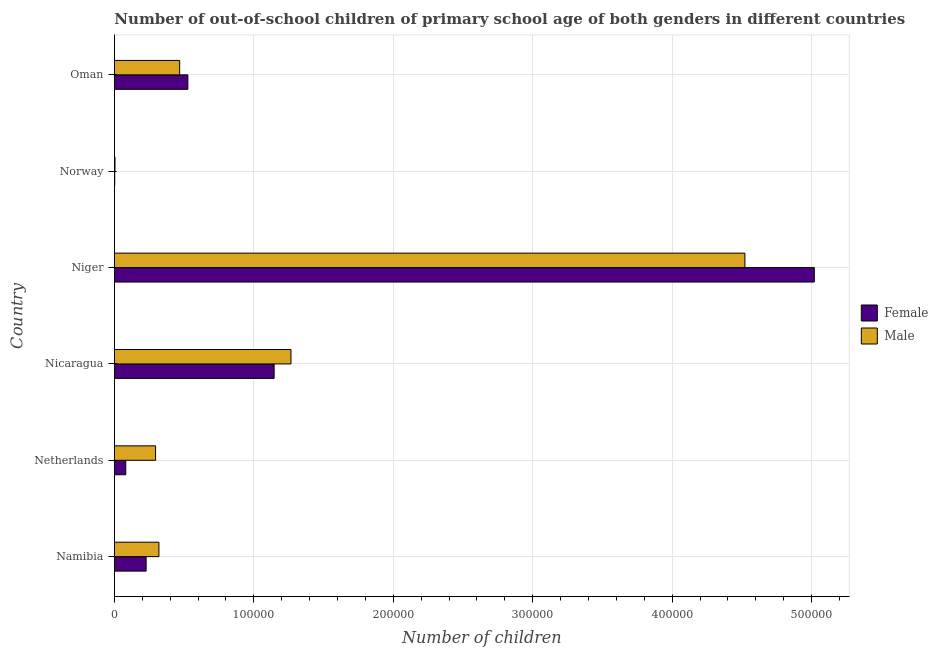How many different coloured bars are there?
Your answer should be compact. 2. Are the number of bars on each tick of the Y-axis equal?
Provide a succinct answer. Yes. How many bars are there on the 3rd tick from the top?
Your answer should be compact. 2. How many bars are there on the 2nd tick from the bottom?
Your answer should be very brief. 2. What is the number of female out-of-school students in Netherlands?
Keep it short and to the point. 8130. Across all countries, what is the maximum number of male out-of-school students?
Your answer should be very brief. 4.52e+05. Across all countries, what is the minimum number of male out-of-school students?
Keep it short and to the point. 409. In which country was the number of male out-of-school students maximum?
Provide a short and direct response. Niger. In which country was the number of male out-of-school students minimum?
Provide a succinct answer. Norway. What is the total number of male out-of-school students in the graph?
Ensure brevity in your answer.  6.87e+05. What is the difference between the number of female out-of-school students in Netherlands and that in Niger?
Your answer should be very brief. -4.94e+05. What is the difference between the number of male out-of-school students in Niger and the number of female out-of-school students in Oman?
Ensure brevity in your answer.  3.99e+05. What is the average number of male out-of-school students per country?
Ensure brevity in your answer.  1.15e+05. What is the difference between the number of female out-of-school students and number of male out-of-school students in Oman?
Provide a succinct answer. 5866. What is the ratio of the number of male out-of-school students in Nicaragua to that in Norway?
Offer a very short reply. 309.54. Is the difference between the number of male out-of-school students in Nicaragua and Niger greater than the difference between the number of female out-of-school students in Nicaragua and Niger?
Give a very brief answer. Yes. What is the difference between the highest and the second highest number of female out-of-school students?
Make the answer very short. 3.87e+05. What is the difference between the highest and the lowest number of female out-of-school students?
Give a very brief answer. 5.02e+05. Is the sum of the number of female out-of-school students in Nicaragua and Niger greater than the maximum number of male out-of-school students across all countries?
Ensure brevity in your answer.  Yes. What does the 2nd bar from the bottom in Niger represents?
Offer a very short reply. Male. Are all the bars in the graph horizontal?
Ensure brevity in your answer.  Yes. Are the values on the major ticks of X-axis written in scientific E-notation?
Your answer should be compact. No. Where does the legend appear in the graph?
Your response must be concise. Center right. What is the title of the graph?
Keep it short and to the point. Number of out-of-school children of primary school age of both genders in different countries. Does "Export" appear as one of the legend labels in the graph?
Make the answer very short. No. What is the label or title of the X-axis?
Offer a terse response. Number of children. What is the label or title of the Y-axis?
Keep it short and to the point. Country. What is the Number of children in Female in Namibia?
Provide a short and direct response. 2.27e+04. What is the Number of children of Male in Namibia?
Your answer should be compact. 3.19e+04. What is the Number of children in Female in Netherlands?
Offer a very short reply. 8130. What is the Number of children in Male in Netherlands?
Give a very brief answer. 2.95e+04. What is the Number of children in Female in Nicaragua?
Offer a terse response. 1.15e+05. What is the Number of children in Male in Nicaragua?
Your answer should be compact. 1.27e+05. What is the Number of children in Female in Niger?
Give a very brief answer. 5.02e+05. What is the Number of children of Male in Niger?
Offer a very short reply. 4.52e+05. What is the Number of children in Female in Norway?
Offer a very short reply. 216. What is the Number of children of Male in Norway?
Provide a short and direct response. 409. What is the Number of children of Female in Oman?
Provide a succinct answer. 5.26e+04. What is the Number of children of Male in Oman?
Ensure brevity in your answer.  4.68e+04. Across all countries, what is the maximum Number of children in Female?
Your answer should be very brief. 5.02e+05. Across all countries, what is the maximum Number of children of Male?
Your answer should be compact. 4.52e+05. Across all countries, what is the minimum Number of children of Female?
Your answer should be compact. 216. Across all countries, what is the minimum Number of children of Male?
Give a very brief answer. 409. What is the total Number of children of Female in the graph?
Provide a short and direct response. 7.00e+05. What is the total Number of children in Male in the graph?
Your answer should be compact. 6.87e+05. What is the difference between the Number of children in Female in Namibia and that in Netherlands?
Offer a very short reply. 1.46e+04. What is the difference between the Number of children of Male in Namibia and that in Netherlands?
Offer a terse response. 2398. What is the difference between the Number of children of Female in Namibia and that in Nicaragua?
Ensure brevity in your answer.  -9.18e+04. What is the difference between the Number of children in Male in Namibia and that in Nicaragua?
Offer a terse response. -9.47e+04. What is the difference between the Number of children of Female in Namibia and that in Niger?
Offer a terse response. -4.79e+05. What is the difference between the Number of children of Male in Namibia and that in Niger?
Your answer should be very brief. -4.20e+05. What is the difference between the Number of children of Female in Namibia and that in Norway?
Offer a terse response. 2.25e+04. What is the difference between the Number of children of Male in Namibia and that in Norway?
Your answer should be very brief. 3.15e+04. What is the difference between the Number of children of Female in Namibia and that in Oman?
Your response must be concise. -2.99e+04. What is the difference between the Number of children of Male in Namibia and that in Oman?
Ensure brevity in your answer.  -1.49e+04. What is the difference between the Number of children in Female in Netherlands and that in Nicaragua?
Offer a terse response. -1.06e+05. What is the difference between the Number of children of Male in Netherlands and that in Nicaragua?
Offer a very short reply. -9.71e+04. What is the difference between the Number of children of Female in Netherlands and that in Niger?
Offer a very short reply. -4.94e+05. What is the difference between the Number of children of Male in Netherlands and that in Niger?
Make the answer very short. -4.23e+05. What is the difference between the Number of children in Female in Netherlands and that in Norway?
Ensure brevity in your answer.  7914. What is the difference between the Number of children in Male in Netherlands and that in Norway?
Offer a very short reply. 2.91e+04. What is the difference between the Number of children in Female in Netherlands and that in Oman?
Make the answer very short. -4.45e+04. What is the difference between the Number of children of Male in Netherlands and that in Oman?
Keep it short and to the point. -1.73e+04. What is the difference between the Number of children of Female in Nicaragua and that in Niger?
Your answer should be compact. -3.87e+05. What is the difference between the Number of children of Male in Nicaragua and that in Niger?
Provide a short and direct response. -3.26e+05. What is the difference between the Number of children in Female in Nicaragua and that in Norway?
Your response must be concise. 1.14e+05. What is the difference between the Number of children of Male in Nicaragua and that in Norway?
Offer a terse response. 1.26e+05. What is the difference between the Number of children in Female in Nicaragua and that in Oman?
Keep it short and to the point. 6.19e+04. What is the difference between the Number of children in Male in Nicaragua and that in Oman?
Your response must be concise. 7.98e+04. What is the difference between the Number of children in Female in Niger and that in Norway?
Provide a succinct answer. 5.02e+05. What is the difference between the Number of children of Male in Niger and that in Norway?
Ensure brevity in your answer.  4.52e+05. What is the difference between the Number of children of Female in Niger and that in Oman?
Provide a short and direct response. 4.49e+05. What is the difference between the Number of children of Male in Niger and that in Oman?
Provide a succinct answer. 4.05e+05. What is the difference between the Number of children in Female in Norway and that in Oman?
Offer a terse response. -5.24e+04. What is the difference between the Number of children in Male in Norway and that in Oman?
Your answer should be compact. -4.64e+04. What is the difference between the Number of children in Female in Namibia and the Number of children in Male in Netherlands?
Your response must be concise. -6774. What is the difference between the Number of children of Female in Namibia and the Number of children of Male in Nicaragua?
Ensure brevity in your answer.  -1.04e+05. What is the difference between the Number of children of Female in Namibia and the Number of children of Male in Niger?
Make the answer very short. -4.29e+05. What is the difference between the Number of children of Female in Namibia and the Number of children of Male in Norway?
Give a very brief answer. 2.23e+04. What is the difference between the Number of children of Female in Namibia and the Number of children of Male in Oman?
Your answer should be compact. -2.40e+04. What is the difference between the Number of children of Female in Netherlands and the Number of children of Male in Nicaragua?
Provide a short and direct response. -1.18e+05. What is the difference between the Number of children in Female in Netherlands and the Number of children in Male in Niger?
Your answer should be compact. -4.44e+05. What is the difference between the Number of children in Female in Netherlands and the Number of children in Male in Norway?
Your answer should be very brief. 7721. What is the difference between the Number of children of Female in Netherlands and the Number of children of Male in Oman?
Your response must be concise. -3.87e+04. What is the difference between the Number of children in Female in Nicaragua and the Number of children in Male in Niger?
Offer a very short reply. -3.38e+05. What is the difference between the Number of children in Female in Nicaragua and the Number of children in Male in Norway?
Give a very brief answer. 1.14e+05. What is the difference between the Number of children in Female in Nicaragua and the Number of children in Male in Oman?
Provide a succinct answer. 6.77e+04. What is the difference between the Number of children of Female in Niger and the Number of children of Male in Norway?
Make the answer very short. 5.02e+05. What is the difference between the Number of children of Female in Niger and the Number of children of Male in Oman?
Your answer should be compact. 4.55e+05. What is the difference between the Number of children in Female in Norway and the Number of children in Male in Oman?
Give a very brief answer. -4.66e+04. What is the average Number of children in Female per country?
Ensure brevity in your answer.  1.17e+05. What is the average Number of children in Male per country?
Your answer should be compact. 1.15e+05. What is the difference between the Number of children of Female and Number of children of Male in Namibia?
Ensure brevity in your answer.  -9172. What is the difference between the Number of children of Female and Number of children of Male in Netherlands?
Keep it short and to the point. -2.14e+04. What is the difference between the Number of children of Female and Number of children of Male in Nicaragua?
Offer a very short reply. -1.21e+04. What is the difference between the Number of children in Female and Number of children in Male in Niger?
Keep it short and to the point. 4.98e+04. What is the difference between the Number of children of Female and Number of children of Male in Norway?
Provide a short and direct response. -193. What is the difference between the Number of children of Female and Number of children of Male in Oman?
Ensure brevity in your answer.  5866. What is the ratio of the Number of children in Female in Namibia to that in Netherlands?
Offer a very short reply. 2.8. What is the ratio of the Number of children of Male in Namibia to that in Netherlands?
Give a very brief answer. 1.08. What is the ratio of the Number of children of Female in Namibia to that in Nicaragua?
Provide a short and direct response. 0.2. What is the ratio of the Number of children in Male in Namibia to that in Nicaragua?
Ensure brevity in your answer.  0.25. What is the ratio of the Number of children of Female in Namibia to that in Niger?
Provide a succinct answer. 0.05. What is the ratio of the Number of children in Male in Namibia to that in Niger?
Offer a terse response. 0.07. What is the ratio of the Number of children in Female in Namibia to that in Norway?
Your answer should be very brief. 105.26. What is the ratio of the Number of children in Male in Namibia to that in Norway?
Your answer should be compact. 78.01. What is the ratio of the Number of children of Female in Namibia to that in Oman?
Ensure brevity in your answer.  0.43. What is the ratio of the Number of children in Male in Namibia to that in Oman?
Your answer should be very brief. 0.68. What is the ratio of the Number of children in Female in Netherlands to that in Nicaragua?
Offer a very short reply. 0.07. What is the ratio of the Number of children in Male in Netherlands to that in Nicaragua?
Your answer should be compact. 0.23. What is the ratio of the Number of children of Female in Netherlands to that in Niger?
Provide a succinct answer. 0.02. What is the ratio of the Number of children in Male in Netherlands to that in Niger?
Ensure brevity in your answer.  0.07. What is the ratio of the Number of children of Female in Netherlands to that in Norway?
Your response must be concise. 37.64. What is the ratio of the Number of children of Male in Netherlands to that in Norway?
Your answer should be compact. 72.15. What is the ratio of the Number of children of Female in Netherlands to that in Oman?
Make the answer very short. 0.15. What is the ratio of the Number of children in Male in Netherlands to that in Oman?
Make the answer very short. 0.63. What is the ratio of the Number of children of Female in Nicaragua to that in Niger?
Give a very brief answer. 0.23. What is the ratio of the Number of children of Male in Nicaragua to that in Niger?
Your answer should be compact. 0.28. What is the ratio of the Number of children in Female in Nicaragua to that in Norway?
Ensure brevity in your answer.  530.19. What is the ratio of the Number of children of Male in Nicaragua to that in Norway?
Your response must be concise. 309.54. What is the ratio of the Number of children in Female in Nicaragua to that in Oman?
Your response must be concise. 2.18. What is the ratio of the Number of children of Male in Nicaragua to that in Oman?
Offer a terse response. 2.71. What is the ratio of the Number of children in Female in Niger to that in Norway?
Your response must be concise. 2323.69. What is the ratio of the Number of children of Male in Niger to that in Norway?
Offer a terse response. 1105.49. What is the ratio of the Number of children in Female in Niger to that in Oman?
Your answer should be very brief. 9.53. What is the ratio of the Number of children of Male in Niger to that in Oman?
Your response must be concise. 9.66. What is the ratio of the Number of children in Female in Norway to that in Oman?
Your response must be concise. 0. What is the ratio of the Number of children in Male in Norway to that in Oman?
Your answer should be compact. 0.01. What is the difference between the highest and the second highest Number of children of Female?
Provide a succinct answer. 3.87e+05. What is the difference between the highest and the second highest Number of children in Male?
Provide a short and direct response. 3.26e+05. What is the difference between the highest and the lowest Number of children of Female?
Your answer should be compact. 5.02e+05. What is the difference between the highest and the lowest Number of children in Male?
Your answer should be compact. 4.52e+05. 